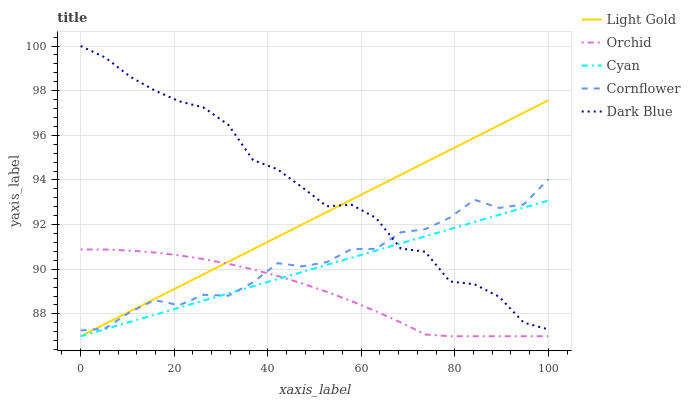Does Light Gold have the minimum area under the curve?
Answer yes or no. No. Does Light Gold have the maximum area under the curve?
Answer yes or no. No. Is Light Gold the smoothest?
Answer yes or no. No. Is Light Gold the roughest?
Answer yes or no. No. Does Dark Blue have the lowest value?
Answer yes or no. No. Does Light Gold have the highest value?
Answer yes or no. No. Is Orchid less than Dark Blue?
Answer yes or no. Yes. Is Dark Blue greater than Orchid?
Answer yes or no. Yes. Does Orchid intersect Dark Blue?
Answer yes or no. No. 